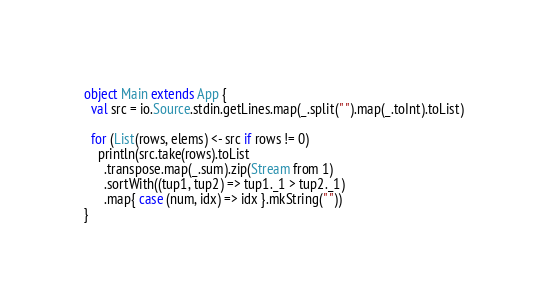Convert code to text. <code><loc_0><loc_0><loc_500><loc_500><_Scala_>object Main extends App {
  val src = io.Source.stdin.getLines.map(_.split(" ").map(_.toInt).toList)

  for (List(rows, elems) <- src if rows != 0)
    println(src.take(rows).toList
      .transpose.map(_.sum).zip(Stream from 1)
      .sortWith((tup1, tup2) => tup1._1 > tup2._1)
      .map{ case (num, idx) => idx }.mkString(" "))
}

</code> 